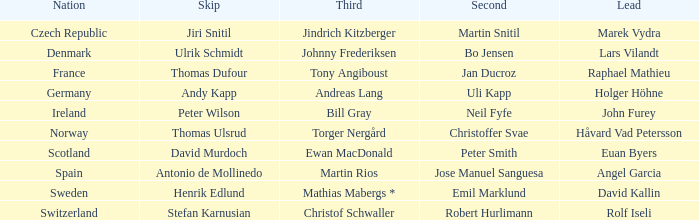Can you parse all the data within this table? {'header': ['Nation', 'Skip', 'Third', 'Second', 'Lead'], 'rows': [['Czech Republic', 'Jiri Snitil', 'Jindrich Kitzberger', 'Martin Snitil', 'Marek Vydra'], ['Denmark', 'Ulrik Schmidt', 'Johnny Frederiksen', 'Bo Jensen', 'Lars Vilandt'], ['France', 'Thomas Dufour', 'Tony Angiboust', 'Jan Ducroz', 'Raphael Mathieu'], ['Germany', 'Andy Kapp', 'Andreas Lang', 'Uli Kapp', 'Holger Höhne'], ['Ireland', 'Peter Wilson', 'Bill Gray', 'Neil Fyfe', 'John Furey'], ['Norway', 'Thomas Ulsrud', 'Torger Nergård', 'Christoffer Svae', 'Håvard Vad Petersson'], ['Scotland', 'David Murdoch', 'Ewan MacDonald', 'Peter Smith', 'Euan Byers'], ['Spain', 'Antonio de Mollinedo', 'Martin Rios', 'Jose Manuel Sanguesa', 'Angel Garcia'], ['Sweden', 'Henrik Edlund', 'Mathias Mabergs *', 'Emil Marklund', 'David Kallin'], ['Switzerland', 'Stefan Karnusian', 'Christof Schwaller', 'Robert Hurlimann', 'Rolf Iseli']]} Which leader is associated with the nation of switzerland? Rolf Iseli. 